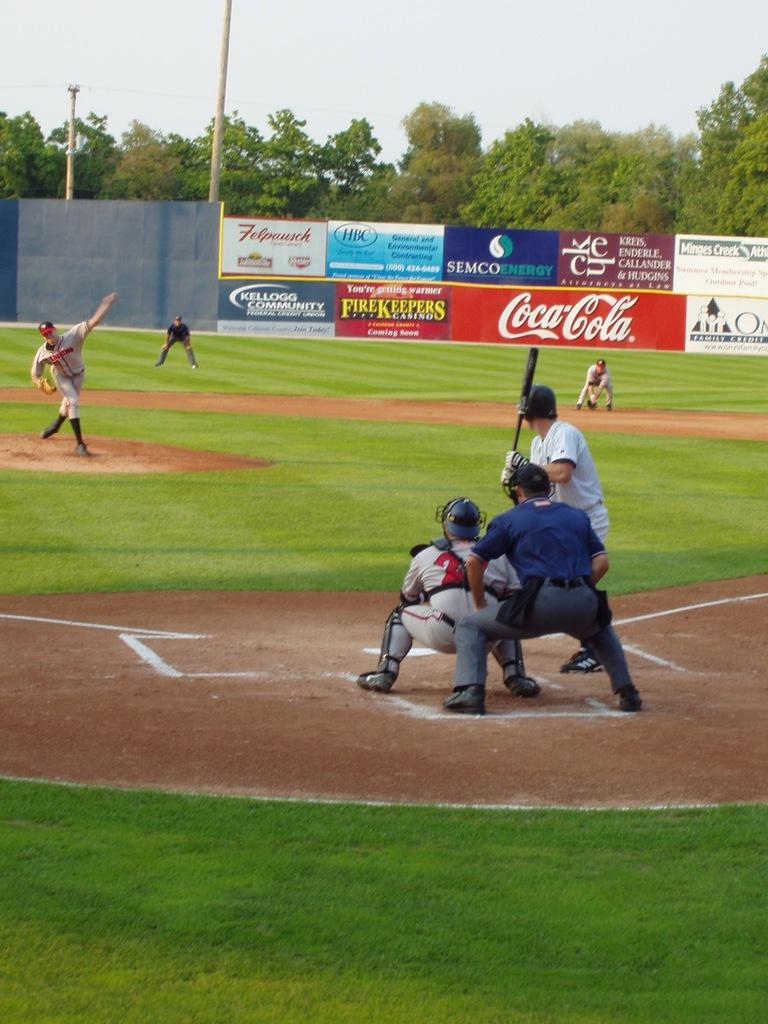What is the phrase coupled with the firekeepers advertisement?
Keep it short and to the point. You're getting warmer. 